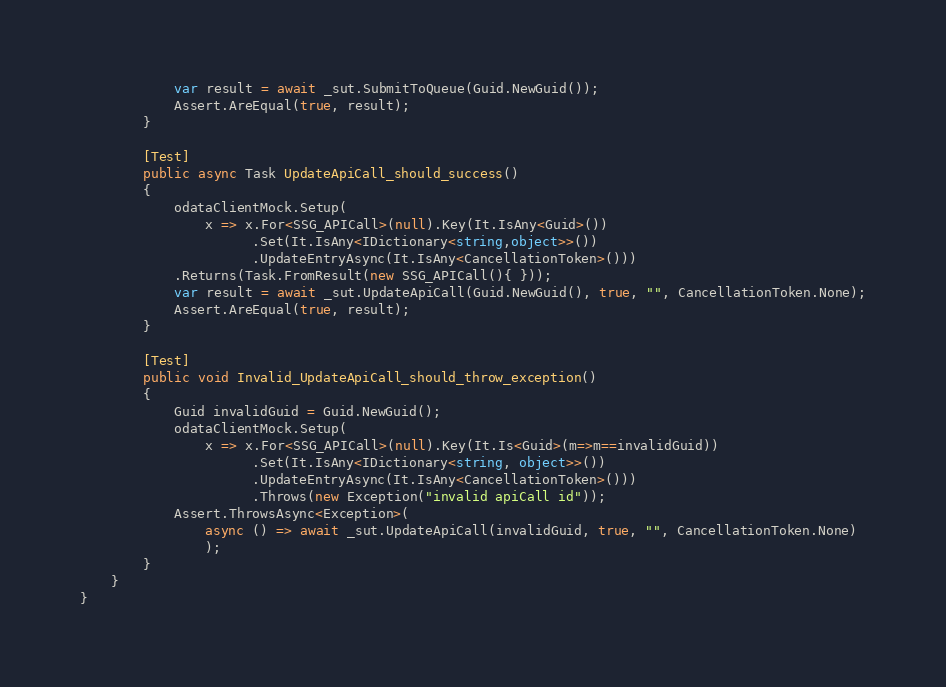Convert code to text. <code><loc_0><loc_0><loc_500><loc_500><_C#_>            var result = await _sut.SubmitToQueue(Guid.NewGuid());
            Assert.AreEqual(true, result);
        }

        [Test]
        public async Task UpdateApiCall_should_success()
        {
            odataClientMock.Setup(
                x => x.For<SSG_APICall>(null).Key(It.IsAny<Guid>())
                      .Set(It.IsAny<IDictionary<string,object>>())
                      .UpdateEntryAsync(It.IsAny<CancellationToken>()))
            .Returns(Task.FromResult(new SSG_APICall(){ }));
            var result = await _sut.UpdateApiCall(Guid.NewGuid(), true, "", CancellationToken.None);
            Assert.AreEqual(true, result);
        }

        [Test]
        public void Invalid_UpdateApiCall_should_throw_exception()
        {
            Guid invalidGuid = Guid.NewGuid();
            odataClientMock.Setup(
                x => x.For<SSG_APICall>(null).Key(It.Is<Guid>(m=>m==invalidGuid))
                      .Set(It.IsAny<IDictionary<string, object>>())
                      .UpdateEntryAsync(It.IsAny<CancellationToken>()))
                      .Throws(new Exception("invalid apiCall id"));
            Assert.ThrowsAsync<Exception>(
                async () => await _sut.UpdateApiCall(invalidGuid, true, "", CancellationToken.None)
                );
        }
    }
}
</code> 